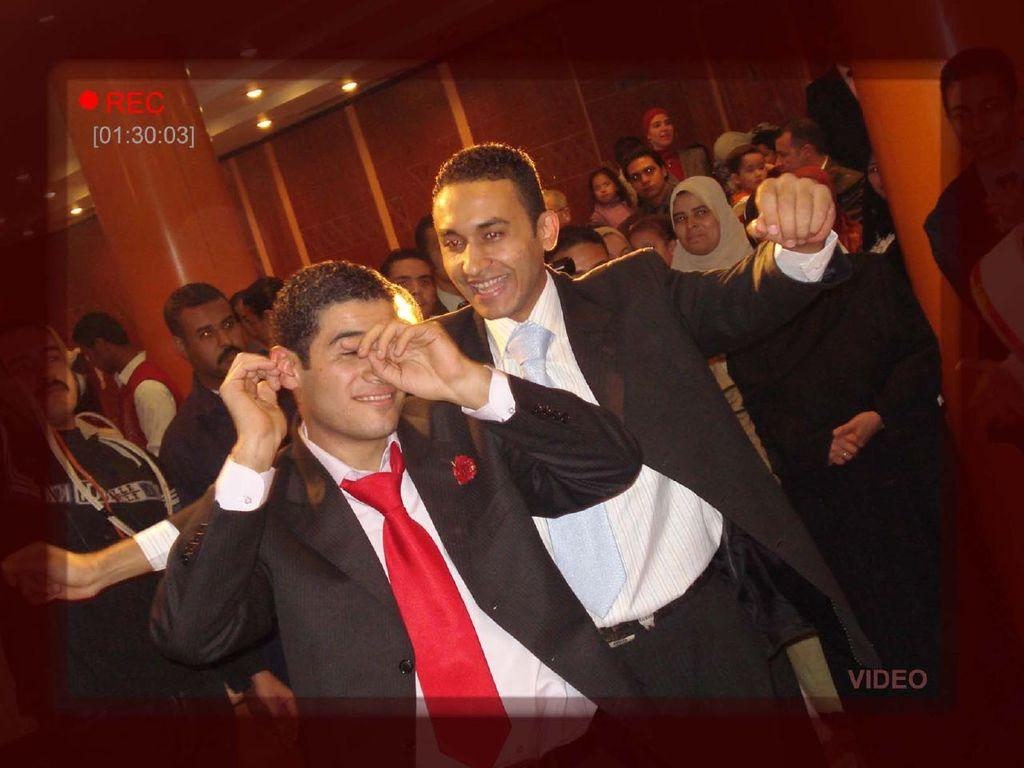Who or what can be seen in the image? There are people in the image. What architectural features are visible in the background? There are pillars and a wall in the background of the image. What can be seen at the top of the image? There are lights visible at the top of the image. What type of elbow design can be seen on the pillars in the image? There is no mention of elbow design in the provided facts, and the image does not show any details about the pillars' design. 